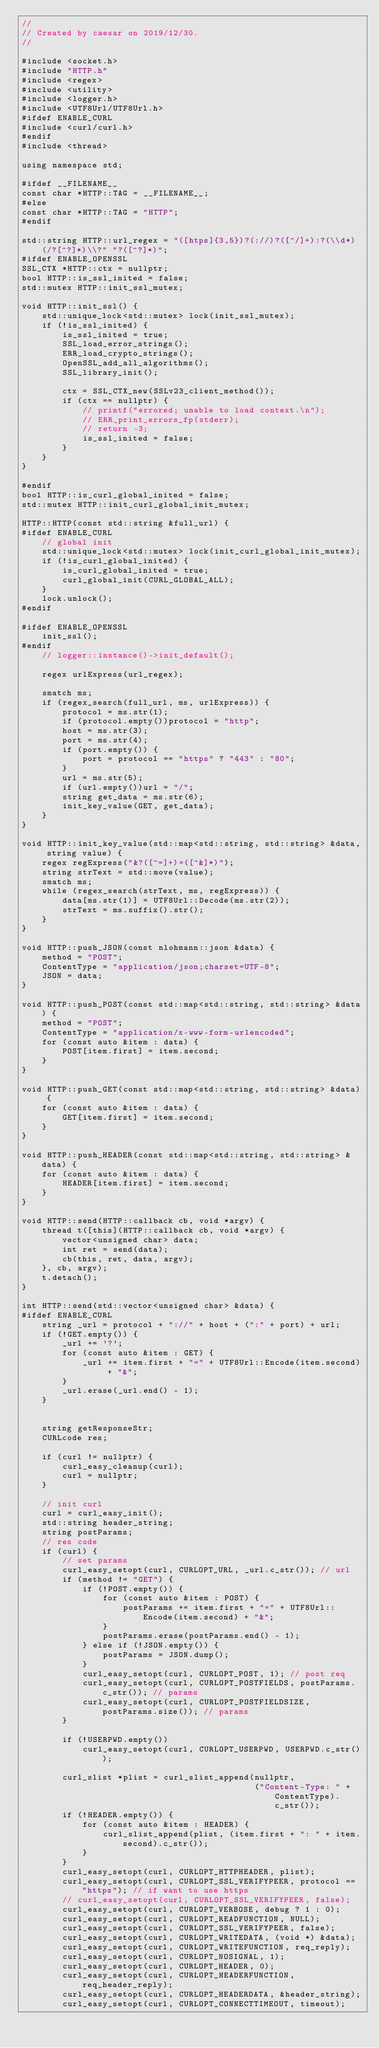Convert code to text. <code><loc_0><loc_0><loc_500><loc_500><_C++_>//
// Created by caesar on 2019/12/30.
//

#include <socket.h>
#include "HTTP.h"
#include <regex>
#include <utility>
#include <logger.h>
#include <UTF8Url/UTF8Url.h>
#ifdef ENABLE_CURL
#include <curl/curl.h>
#endif
#include <thread>

using namespace std;

#ifdef __FILENAME__
const char *HTTP::TAG = __FILENAME__;
#else
const char *HTTP::TAG = "HTTP";
#endif

std::string HTTP::url_regex = "([htps]{3,5})?(://)?([^/]+):?(\\d*)(/?[^?]*)\\?" "?([^?]*)";
#ifdef ENABLE_OPENSSL
SSL_CTX *HTTP::ctx = nullptr;
bool HTTP::is_ssl_inited = false;
std::mutex HTTP::init_ssl_mutex;

void HTTP::init_ssl() {
    std::unique_lock<std::mutex> lock(init_ssl_mutex);
    if (!is_ssl_inited) {
        is_ssl_inited = true;
        SSL_load_error_strings();
        ERR_load_crypto_strings();
        OpenSSL_add_all_algorithms();
        SSL_library_init();

        ctx = SSL_CTX_new(SSLv23_client_method());
        if (ctx == nullptr) {
            // printf("errored; unable to load context.\n");
            // ERR_print_errors_fp(stderr);
            // return -3;
            is_ssl_inited = false;
        }
    }
}

#endif
bool HTTP::is_curl_global_inited = false;
std::mutex HTTP::init_curl_global_init_mutex;

HTTP::HTTP(const std::string &full_url) {
#ifdef ENABLE_CURL
    // global init
    std::unique_lock<std::mutex> lock(init_curl_global_init_mutex);
    if (!is_curl_global_inited) {
        is_curl_global_inited = true;
        curl_global_init(CURL_GLOBAL_ALL);
    }
    lock.unlock();
#endif

#ifdef ENABLE_OPENSSL
    init_ssl();
#endif
    // logger::instance()->init_default();

    regex urlExpress(url_regex);

    smatch ms;
    if (regex_search(full_url, ms, urlExpress)) {
        protocol = ms.str(1);
        if (protocol.empty())protocol = "http";
        host = ms.str(3);
        port = ms.str(4);
        if (port.empty()) {
            port = protocol == "https" ? "443" : "80";
        }
        url = ms.str(5);
        if (url.empty())url = "/";
        string get_data = ms.str(6);
        init_key_value(GET, get_data);
    }
}

void HTTP::init_key_value(std::map<std::string, std::string> &data, string value) {
    regex regExpress("&?([^=]+)=([^&]*)");
    string strText = std::move(value);
    smatch ms;
    while (regex_search(strText, ms, regExpress)) {
        data[ms.str(1)] = UTF8Url::Decode(ms.str(2));
        strText = ms.suffix().str();
    }
}

void HTTP::push_JSON(const nlohmann::json &data) {
    method = "POST";
    ContentType = "application/json;charset=UTF-8";
    JSON = data;
}

void HTTP::push_POST(const std::map<std::string, std::string> &data) {
    method = "POST";
    ContentType = "application/x-www-form-urlencoded";
    for (const auto &item : data) {
        POST[item.first] = item.second;
    }
}

void HTTP::push_GET(const std::map<std::string, std::string> &data) {
    for (const auto &item : data) {
        GET[item.first] = item.second;
    }
}

void HTTP::push_HEADER(const std::map<std::string, std::string> &data) {
    for (const auto &item : data) {
        HEADER[item.first] = item.second;
    }
}

void HTTP::send(HTTP::callback cb, void *argv) {
    thread t([this](HTTP::callback cb, void *argv) {
        vector<unsigned char> data;
        int ret = send(data);
        cb(this, ret, data, argv);
    }, cb, argv);
    t.detach();
}

int HTTP::send(std::vector<unsigned char> &data) {
#ifdef ENABLE_CURL
    string _url = protocol + "://" + host + (":" + port) + url;
    if (!GET.empty()) {
        _url += '?';
        for (const auto &item : GET) {
            _url += item.first + "=" + UTF8Url::Encode(item.second) + "&";
        }
        _url.erase(_url.end() - 1);
    }


    string getResponseStr;
    CURLcode res;

    if (curl != nullptr) {
        curl_easy_cleanup(curl);
        curl = nullptr;
    }

    // init curl
    curl = curl_easy_init();
    std::string header_string;
    string postParams;
    // res code
    if (curl) {
        // set params
        curl_easy_setopt(curl, CURLOPT_URL, _url.c_str()); // url
        if (method != "GET") {
            if (!POST.empty()) {
                for (const auto &item : POST) {
                    postParams += item.first + "=" + UTF8Url::Encode(item.second) + "&";
                }
                postParams.erase(postParams.end() - 1);
            } else if (!JSON.empty()) {
                postParams = JSON.dump();
            }
            curl_easy_setopt(curl, CURLOPT_POST, 1); // post req
            curl_easy_setopt(curl, CURLOPT_POSTFIELDS, postParams.c_str()); // params
            curl_easy_setopt(curl, CURLOPT_POSTFIELDSIZE, postParams.size()); // params
        }

        if (!USERPWD.empty())
            curl_easy_setopt(curl, CURLOPT_USERPWD, USERPWD.c_str());

        curl_slist *plist = curl_slist_append(nullptr,
                                              ("Content-Type: " + ContentType).c_str());
        if (!HEADER.empty()) {
            for (const auto &item : HEADER) {
                curl_slist_append(plist, (item.first + ": " + item.second).c_str());
            }
        }
        curl_easy_setopt(curl, CURLOPT_HTTPHEADER, plist);
        curl_easy_setopt(curl, CURLOPT_SSL_VERIFYPEER, protocol == "https"); // if want to use https
        // curl_easy_setopt(curl, CURLOPT_SSL_VERIFYPEER, false);
        curl_easy_setopt(curl, CURLOPT_VERBOSE, debug ? 1 : 0);
        curl_easy_setopt(curl, CURLOPT_READFUNCTION, NULL);
        curl_easy_setopt(curl, CURLOPT_SSL_VERIFYPEER, false);
        curl_easy_setopt(curl, CURLOPT_WRITEDATA, (void *) &data);
        curl_easy_setopt(curl, CURLOPT_WRITEFUNCTION, req_reply);
        curl_easy_setopt(curl, CURLOPT_NOSIGNAL, 1);
        curl_easy_setopt(curl, CURLOPT_HEADER, 0);
        curl_easy_setopt(curl, CURLOPT_HEADERFUNCTION, req_header_reply);
        curl_easy_setopt(curl, CURLOPT_HEADERDATA, &header_string);
        curl_easy_setopt(curl, CURLOPT_CONNECTTIMEOUT, timeout);</code> 